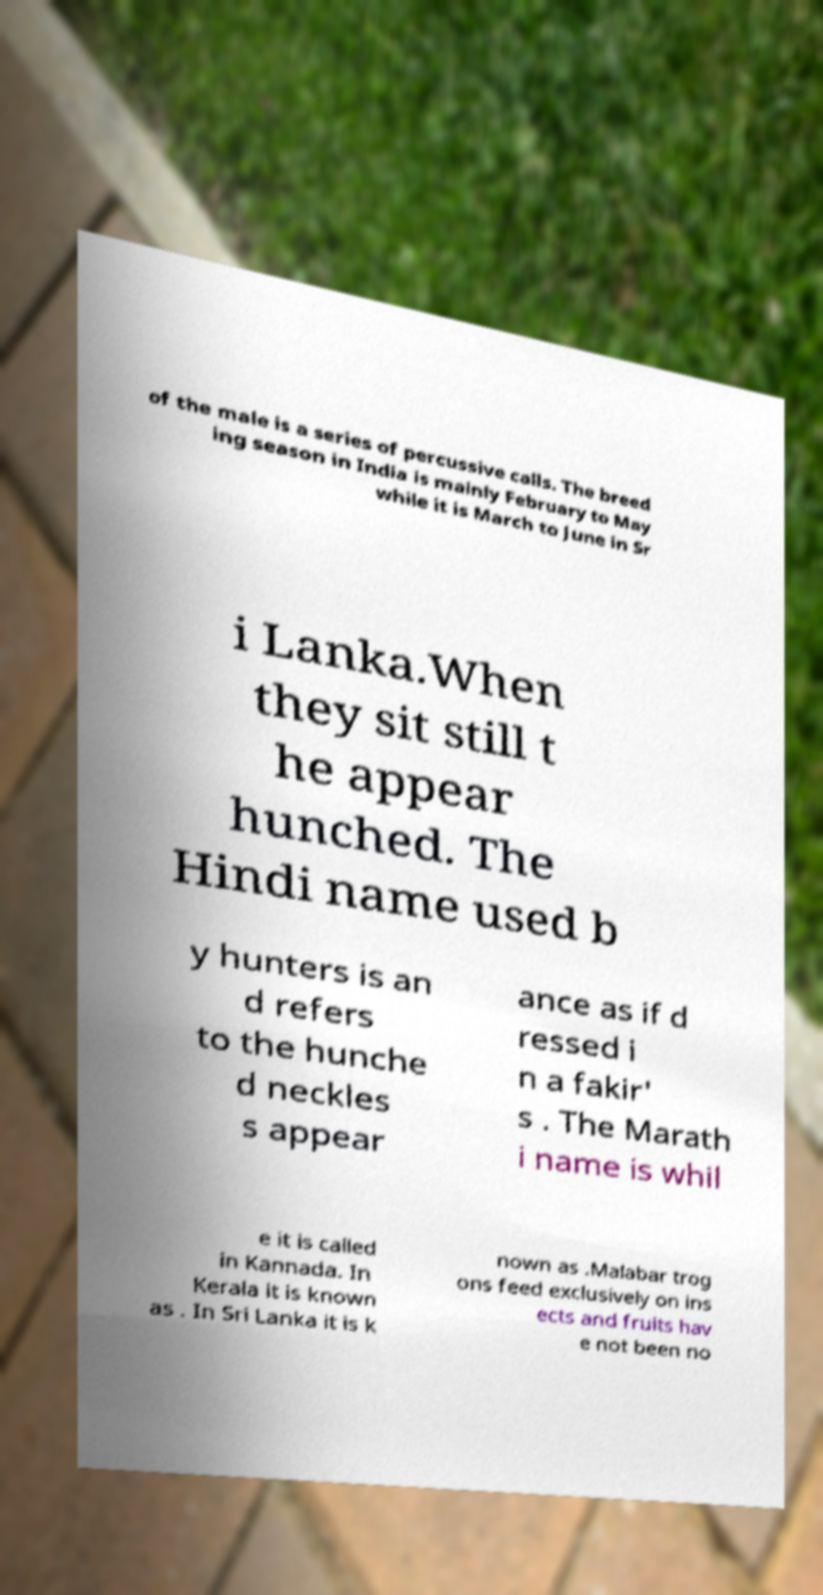There's text embedded in this image that I need extracted. Can you transcribe it verbatim? of the male is a series of percussive calls. The breed ing season in India is mainly February to May while it is March to June in Sr i Lanka.When they sit still t he appear hunched. The Hindi name used b y hunters is an d refers to the hunche d neckles s appear ance as if d ressed i n a fakir' s . The Marath i name is whil e it is called in Kannada. In Kerala it is known as . In Sri Lanka it is k nown as .Malabar trog ons feed exclusively on ins ects and fruits hav e not been no 